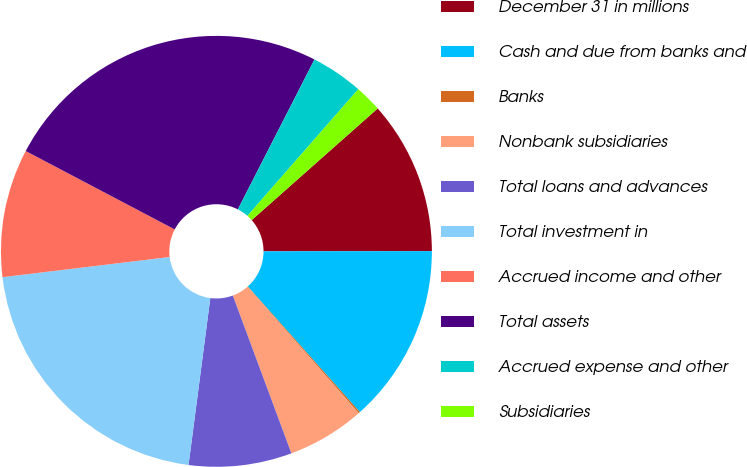Convert chart. <chart><loc_0><loc_0><loc_500><loc_500><pie_chart><fcel>December 31 in millions<fcel>Cash and due from banks and<fcel>Banks<fcel>Nonbank subsidiaries<fcel>Total loans and advances<fcel>Total investment in<fcel>Accrued income and other<fcel>Total assets<fcel>Accrued expense and other<fcel>Subsidiaries<nl><fcel>11.52%<fcel>13.42%<fcel>0.12%<fcel>5.82%<fcel>7.72%<fcel>21.02%<fcel>9.62%<fcel>24.81%<fcel>3.92%<fcel>2.02%<nl></chart> 